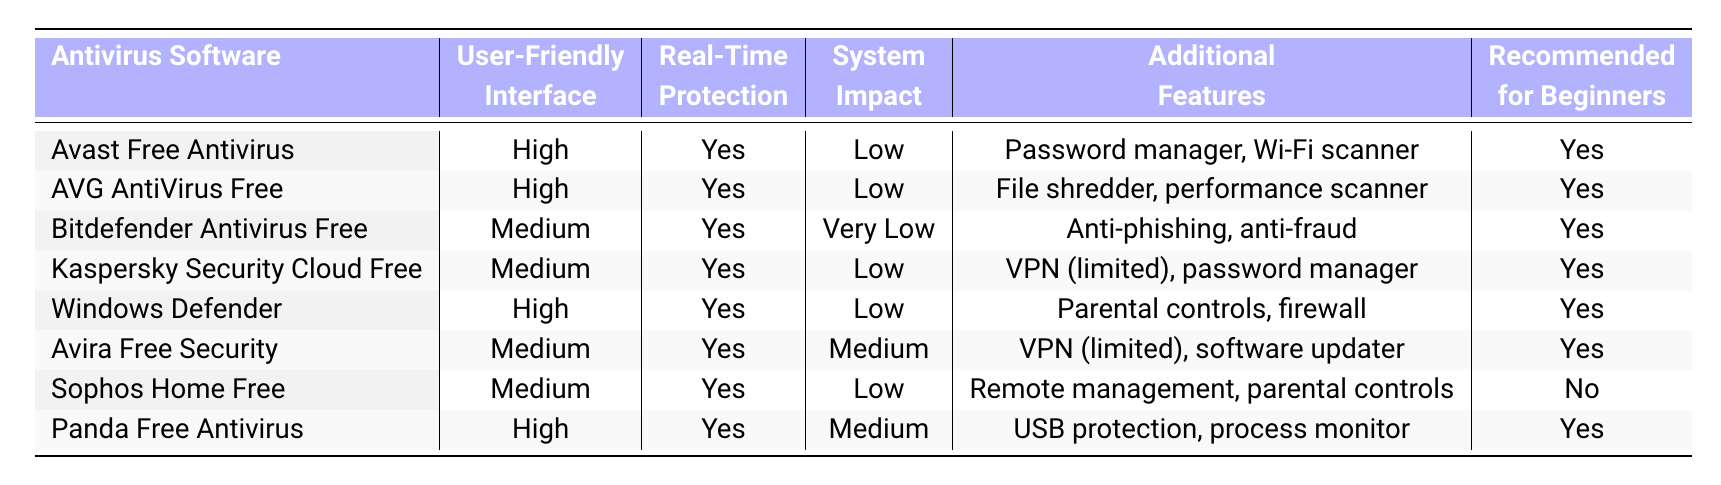What antivirus software options are recommended for beginners? The table indicates that the antivirus software options recommended for beginners are Avast Free Antivirus, AVG AntiVirus Free, Bitdefender Antivirus Free, Kaspersky Security Cloud Free, Windows Defender, Avira Free Security, and Panda Free Antivirus.
Answer: Avast Free Antivirus, AVG AntiVirus Free, Bitdefender Antivirus Free, Kaspersky Security Cloud Free, Windows Defender, Avira Free Security, Panda Free Antivirus Which antivirus software has the highest user-friendly interface rating? The table shows that both Avast Free Antivirus and AVG AntiVirus Free have a 'High' rating for user-friendly interface, which is the highest rating mentioned.
Answer: Avast Free Antivirus, AVG AntiVirus Free Is Panda Free Antivirus suitable for beginners? According to the table, Panda Free Antivirus is marked as 'Yes' for being recommended for beginners.
Answer: Yes How many antivirus programs have real-time protection? The table shows that all listed antivirus programs, including Avast, AVG, Bitdefender, Kaspersky, Windows Defender, Avira, Sophos, and Panda, provide real-time protection, which means there are 8 programs in total.
Answer: 8 Which antivirus program has the lowest system impact? Bitdefender Antivirus Free is indicated as having a 'Very Low' system impact compared to others, making it the antivirus program with the lowest system impact.
Answer: Bitdefender Antivirus Free How many antivirus programs are rated as medium for user-friendly interface? By counting the entries in the table, it shows that there are three antivirus programs with a medium rating for user-friendly interface: Bitdefender Antivirus Free, Kaspersky Security Cloud Free, and Avira Free Security.
Answer: 3 Which antivirus software has the most additional features? The software with the most additional features appears to be Avast Free Antivirus with a password manager and Wi-Fi scanner mentioned alongside AVG’s file shredder and performance scanner, as both have significant features but Avast has two distinct features.
Answer: Avast Free Antivirus Is Sophos Home Free recommended for beginners? The table specifies that Sophos Home Free is marked as 'No' for being recommended for beginners.
Answer: No Which antivirus has a user-friendly interface and is not recommended for beginners? Sophos Home Free has a medium user-friendly interface and is not recommended for beginners according to the table.
Answer: Sophos Home Free How does the system impact of Windows Defender compare to that of Avira Free Security? Windows Defender is listed with a 'Low' system impact while Avira Free Security has a 'Medium' system impact. Thus, Windows Defender is more favorable regarding system impact.
Answer: Windows Defender is better 